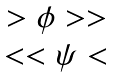<formula> <loc_0><loc_0><loc_500><loc_500>\begin{matrix} > { \phi } > > \\ < < { \psi } < \end{matrix}</formula> 